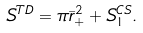<formula> <loc_0><loc_0><loc_500><loc_500>S ^ { T D } = \pi \bar { r } _ { + } ^ { 2 } + S ^ { C S } _ { 1 } .</formula> 